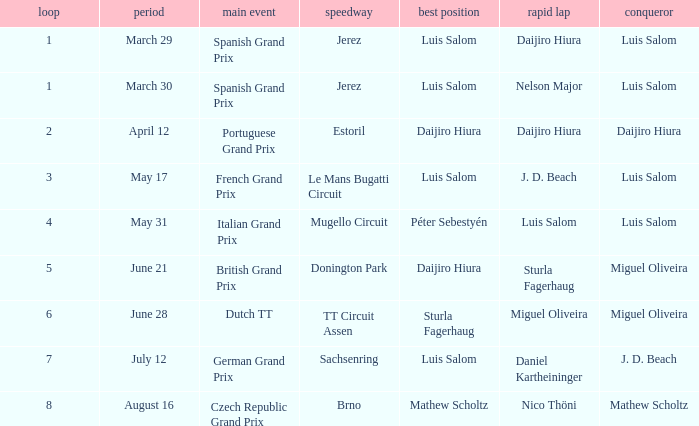Could you parse the entire table as a dict? {'header': ['loop', 'period', 'main event', 'speedway', 'best position', 'rapid lap', 'conqueror'], 'rows': [['1', 'March 29', 'Spanish Grand Prix', 'Jerez', 'Luis Salom', 'Daijiro Hiura', 'Luis Salom'], ['1', 'March 30', 'Spanish Grand Prix', 'Jerez', 'Luis Salom', 'Nelson Major', 'Luis Salom'], ['2', 'April 12', 'Portuguese Grand Prix', 'Estoril', 'Daijiro Hiura', 'Daijiro Hiura', 'Daijiro Hiura'], ['3', 'May 17', 'French Grand Prix', 'Le Mans Bugatti Circuit', 'Luis Salom', 'J. D. Beach', 'Luis Salom'], ['4', 'May 31', 'Italian Grand Prix', 'Mugello Circuit', 'Péter Sebestyén', 'Luis Salom', 'Luis Salom'], ['5', 'June 21', 'British Grand Prix', 'Donington Park', 'Daijiro Hiura', 'Sturla Fagerhaug', 'Miguel Oliveira'], ['6', 'June 28', 'Dutch TT', 'TT Circuit Assen', 'Sturla Fagerhaug', 'Miguel Oliveira', 'Miguel Oliveira'], ['7', 'July 12', 'German Grand Prix', 'Sachsenring', 'Luis Salom', 'Daniel Kartheininger', 'J. D. Beach'], ['8', 'August 16', 'Czech Republic Grand Prix', 'Brno', 'Mathew Scholtz', 'Nico Thöni', 'Mathew Scholtz']]} Who had the fastest lap in the Dutch TT Grand Prix?  Miguel Oliveira. 